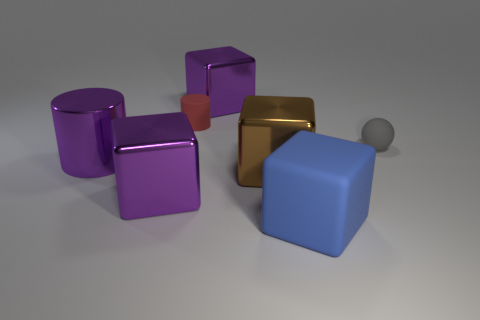Subtract all brown blocks. How many blocks are left? 3 Subtract all cyan cubes. Subtract all blue balls. How many cubes are left? 4 Add 1 rubber cylinders. How many objects exist? 8 Subtract all blocks. How many objects are left? 3 Add 4 purple shiny cubes. How many purple shiny cubes are left? 6 Add 1 tiny green shiny spheres. How many tiny green shiny spheres exist? 1 Subtract 0 yellow spheres. How many objects are left? 7 Subtract all big blue matte objects. Subtract all large brown blocks. How many objects are left? 5 